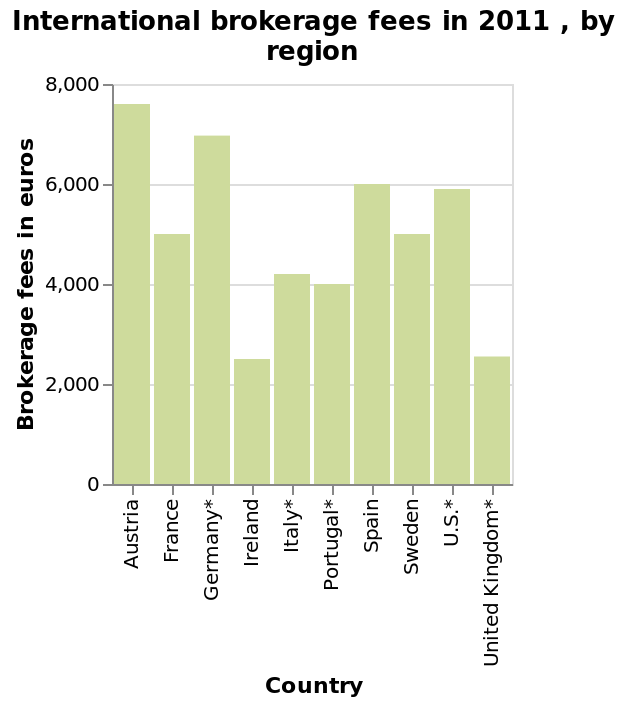<image>
What is the minimum value on the y-axis?  The minimum value on the y-axis is 0 euros. How would you compare the brokerage fees in English-speaking European countries to the rest of the world? The brokerage fees in English-speaking European countries are significantly lower compared to the rest of the world, including the US. 